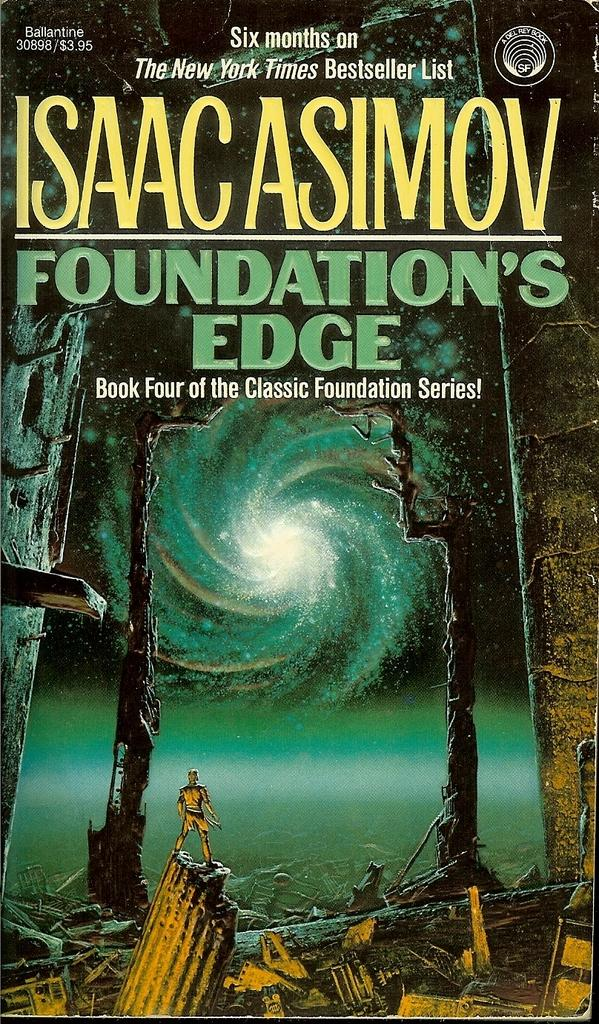<image>
Share a concise interpretation of the image provided. The book "Foundation's Edge" is Book Four of the Classic Foundation Series! 